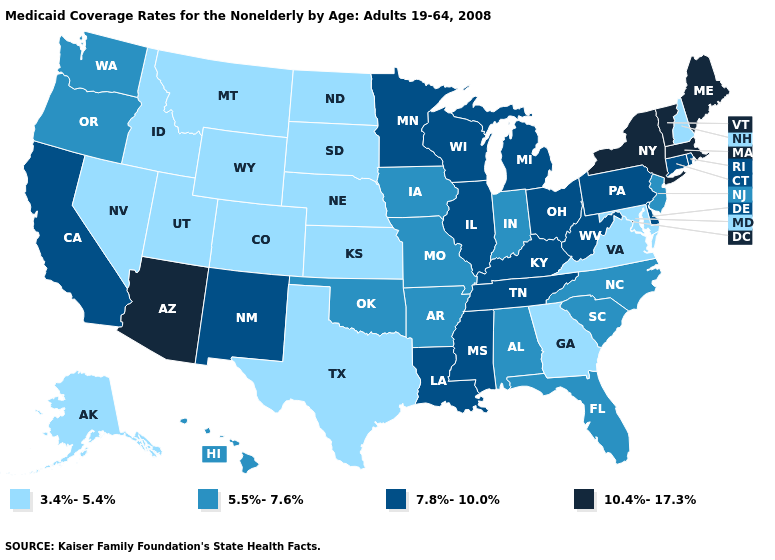Does the first symbol in the legend represent the smallest category?
Keep it brief. Yes. Name the states that have a value in the range 3.4%-5.4%?
Answer briefly. Alaska, Colorado, Georgia, Idaho, Kansas, Maryland, Montana, Nebraska, Nevada, New Hampshire, North Dakota, South Dakota, Texas, Utah, Virginia, Wyoming. Name the states that have a value in the range 3.4%-5.4%?
Short answer required. Alaska, Colorado, Georgia, Idaho, Kansas, Maryland, Montana, Nebraska, Nevada, New Hampshire, North Dakota, South Dakota, Texas, Utah, Virginia, Wyoming. Name the states that have a value in the range 3.4%-5.4%?
Be succinct. Alaska, Colorado, Georgia, Idaho, Kansas, Maryland, Montana, Nebraska, Nevada, New Hampshire, North Dakota, South Dakota, Texas, Utah, Virginia, Wyoming. What is the highest value in the Northeast ?
Be succinct. 10.4%-17.3%. Does the first symbol in the legend represent the smallest category?
Concise answer only. Yes. Does the map have missing data?
Write a very short answer. No. What is the highest value in the South ?
Short answer required. 7.8%-10.0%. Does Nebraska have a lower value than Wyoming?
Quick response, please. No. Name the states that have a value in the range 10.4%-17.3%?
Keep it brief. Arizona, Maine, Massachusetts, New York, Vermont. Name the states that have a value in the range 7.8%-10.0%?
Concise answer only. California, Connecticut, Delaware, Illinois, Kentucky, Louisiana, Michigan, Minnesota, Mississippi, New Mexico, Ohio, Pennsylvania, Rhode Island, Tennessee, West Virginia, Wisconsin. Name the states that have a value in the range 7.8%-10.0%?
Be succinct. California, Connecticut, Delaware, Illinois, Kentucky, Louisiana, Michigan, Minnesota, Mississippi, New Mexico, Ohio, Pennsylvania, Rhode Island, Tennessee, West Virginia, Wisconsin. Name the states that have a value in the range 5.5%-7.6%?
Answer briefly. Alabama, Arkansas, Florida, Hawaii, Indiana, Iowa, Missouri, New Jersey, North Carolina, Oklahoma, Oregon, South Carolina, Washington. What is the lowest value in the USA?
Concise answer only. 3.4%-5.4%. 